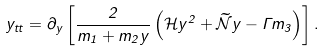<formula> <loc_0><loc_0><loc_500><loc_500>y _ { t t } = \partial _ { y } \left [ \frac { 2 } { m _ { 1 } + m _ { 2 } y } \left ( { \mathcal { H } } y ^ { 2 } + { \widetilde { \mathcal { N } } } y - \Gamma m _ { 3 } \right ) \right ] .</formula> 